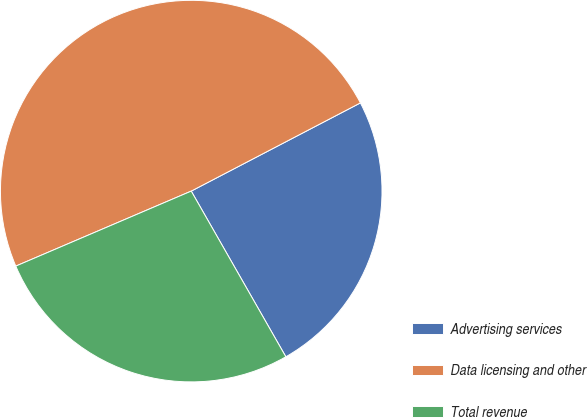Convert chart. <chart><loc_0><loc_0><loc_500><loc_500><pie_chart><fcel>Advertising services<fcel>Data licensing and other<fcel>Total revenue<nl><fcel>24.39%<fcel>48.78%<fcel>26.83%<nl></chart> 